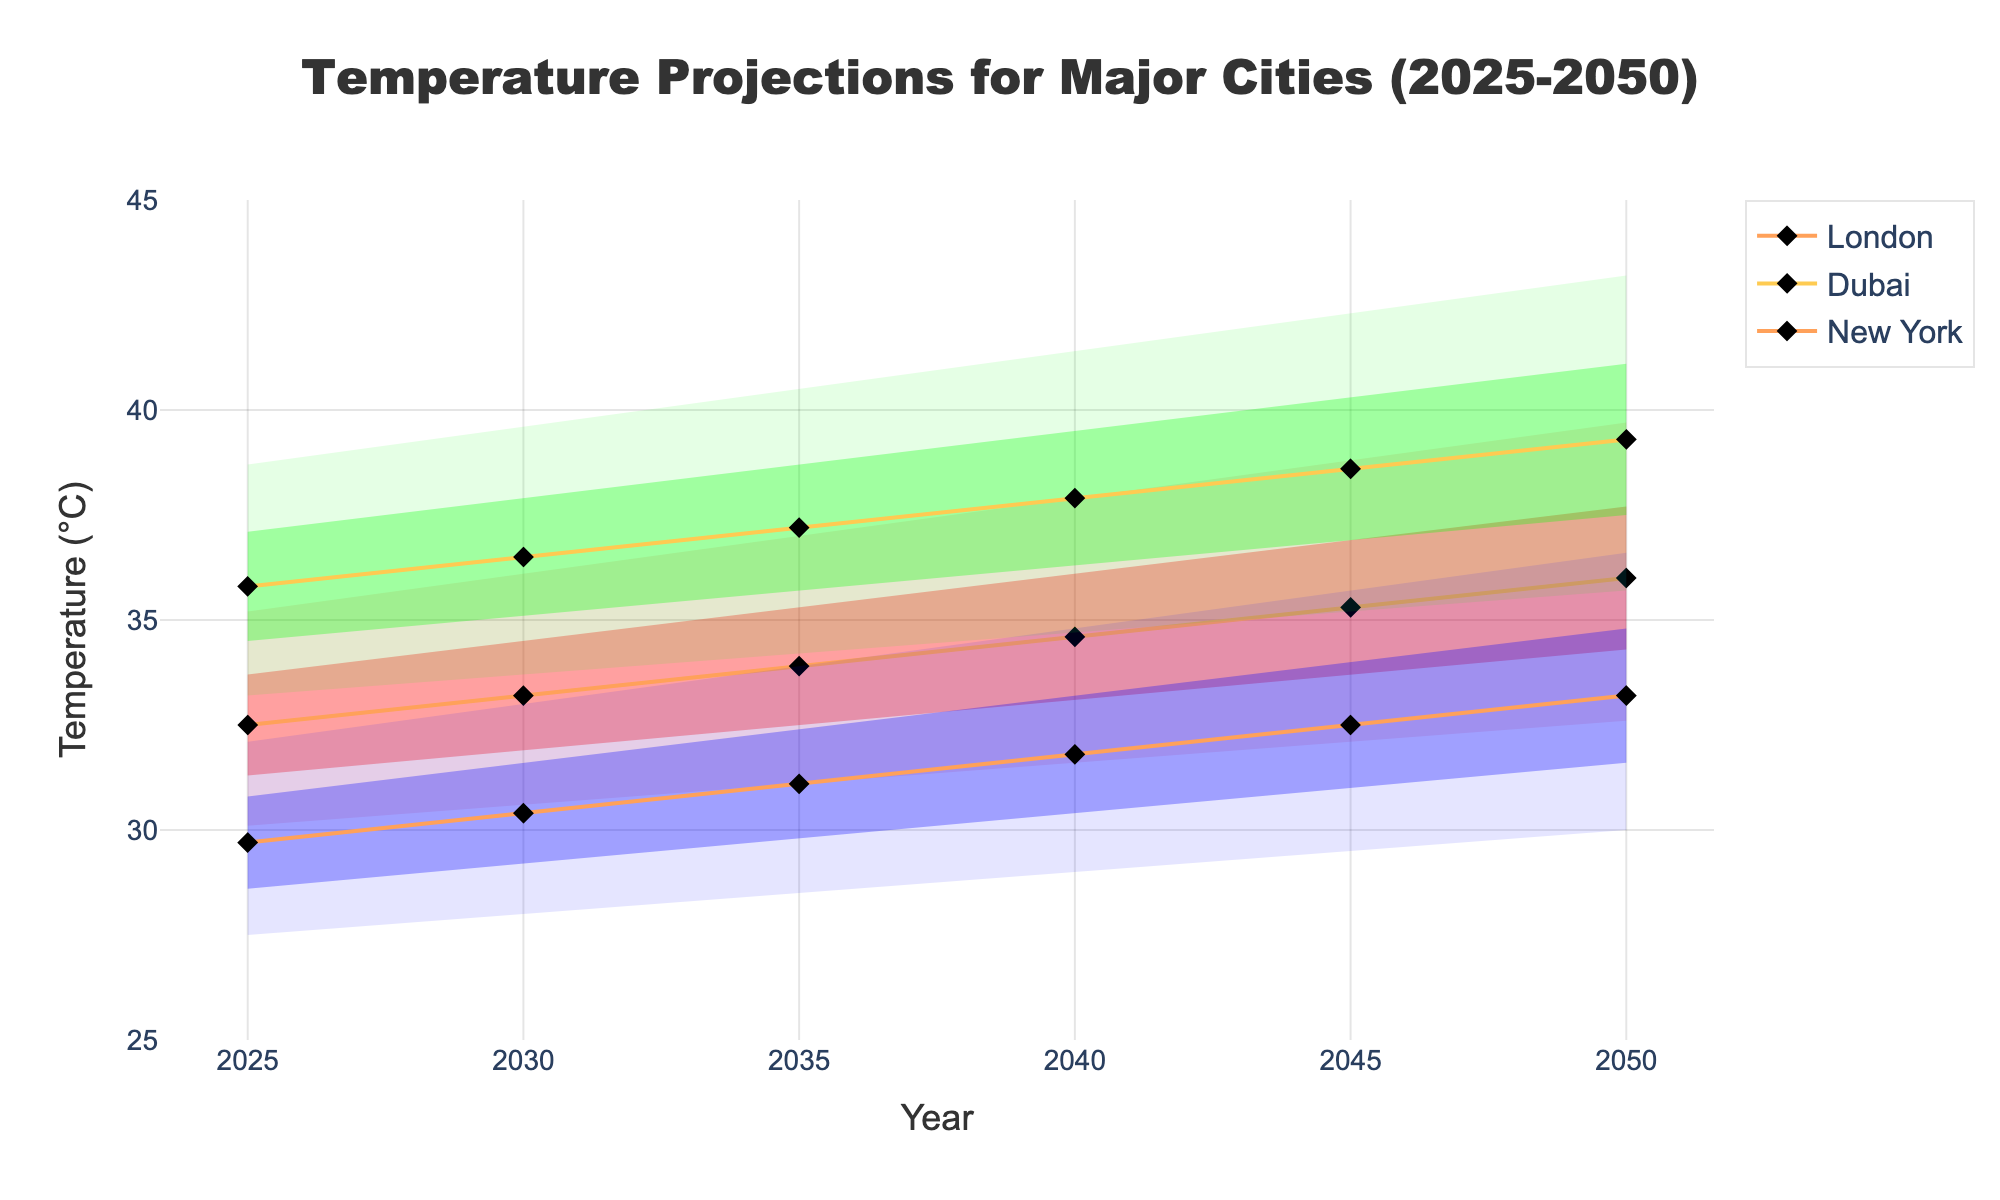What is the title of the figure? The title is displayed at the top center of the figure in large, bold text. It indicates what data the chart represents.
Answer: Temperature Projections for Major Cities (2025-2050) What is the range of years presented on the x-axis? The x-axis contains years tick marks from 2025 to 2050, with a tick interval of five years.
Answer: 2025-2050 Which city shows the highest median temperature in 2050? By looking at the line for the median temperature, we can see that Dubai has the highest value at 39.3°C in 2050.
Answer: Dubai How does the median temperature in New York change from 2025 to 2050? Observing the median temperature line for New York, it increases from 32.5°C in 2025 to 36.0°C in 2050.
Answer: Increases from 32.5°C to 36.0°C Which city shows the widest temperature range between the 10th and 90th percentiles in 2045? By comparing the shaded areas between the 10th and 90th percentiles for each city in 2045, Dubai shows the widest range, with 35.2°C (10th) to 42.3°C (90th).
Answer: Dubai What is the median temperature in London for the year 2035? Looking at the middle line for London in 2035, the median temperature is 31.1°C.
Answer: 31.1°C Which city experiences the smallest increase in median temperature from 2025 to 2050? Calculating the differences: New York (36.0 - 32.5 = 3.5°C), Dubai (39.3 - 35.8 = 3.5°C), London (33.2 - 29.7 = 3.5°C). All cities have the same increase.
Answer: All cities In 2040, which city has the highest 75th percentile temperature? Comparing the 75th percentile line values, Dubai has the highest at 39.5°C in 2040.
Answer: Dubai What are the 10th and 90th percentile temperatures for New York in 2025? Referring to the highest and lowest bands in 2025 for New York: 10th percentile is 30.1°C, and the 90th percentile is 35.2°C.
Answer: 30.1°C and 35.2°C 